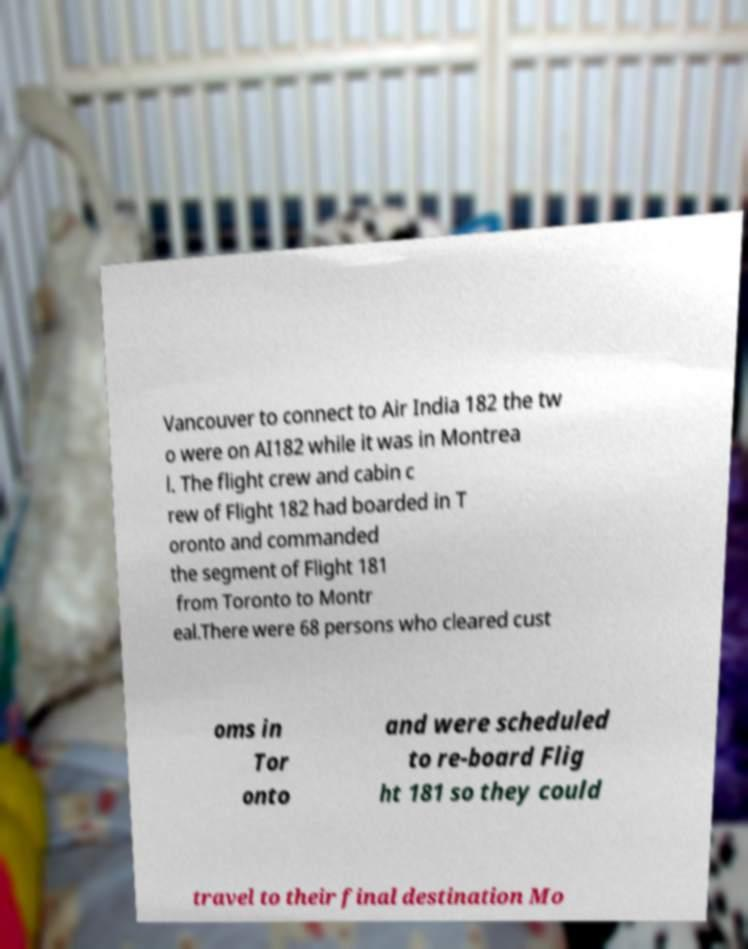Please read and relay the text visible in this image. What does it say? Vancouver to connect to Air India 182 the tw o were on AI182 while it was in Montrea l. The flight crew and cabin c rew of Flight 182 had boarded in T oronto and commanded the segment of Flight 181 from Toronto to Montr eal.There were 68 persons who cleared cust oms in Tor onto and were scheduled to re-board Flig ht 181 so they could travel to their final destination Mo 